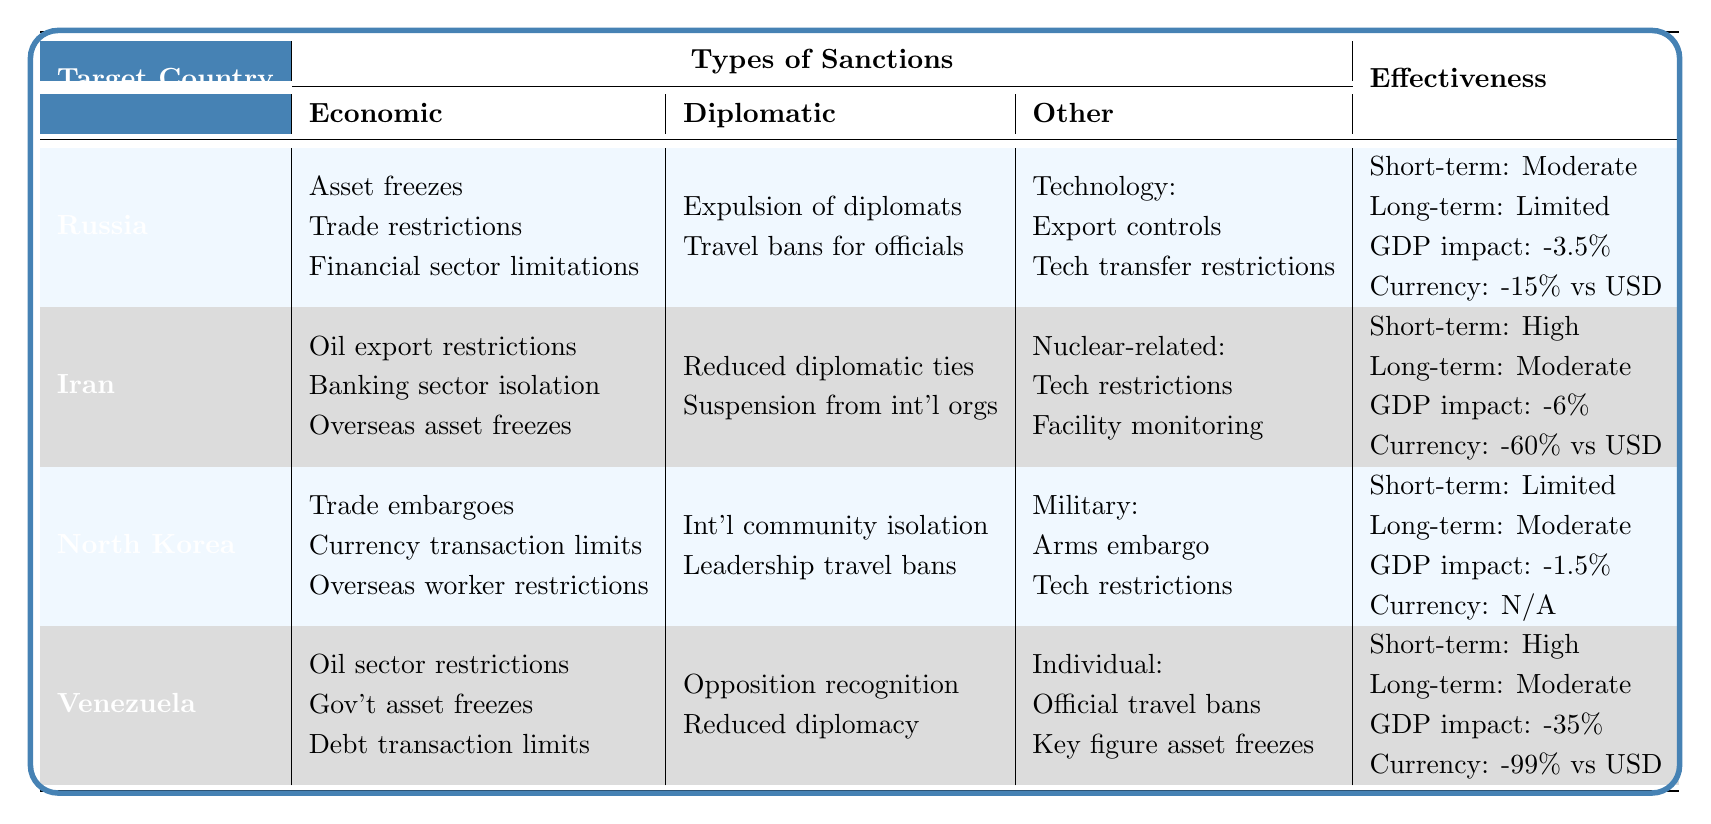What types of economic sanctions are imposed on Russia? From the table, the economic sanctions on Russia include asset freezes, trade restrictions, and financial sector limitations.
Answer: Asset freezes, trade restrictions, financial sector limitations What is the impact on Iran's currency due to sanctions? According to the table, the impact on Iran's currency is a decline of 60% against the USD.
Answer: -60% against USD Is the effectiveness of sanctions on North Korea considered high in the short term? The table indicates that the short-term effectiveness on North Korea is limited, not high.
Answer: No What is the average impact on GDP for the countries listed? To find the average GDP impact, we sum the impacts: -3.5% (Russia) + -6% (Iran) + -1.5% (North Korea) + -35% (Venezuela) = -46%. Then divide by 4 (number of countries), resulting in -46% / 4 = -11.5%.
Answer: -11.5% Do all targeted countries face long-term effectiveness classified as moderate? The table shows that while Iran and Venezuela have moderate long-term effectiveness, Russia has limited effectiveness, so not all do.
Answer: No Which country has the highest short-term effectiveness of sanctions? The table indicates that both Iran and Venezuela have high short-term effectiveness, but since the question asks for the highest, we refer to their equal status.
Answer: Iran and Venezuela What is the difference in GDP impact between Venezuela and North Korea? The GDP impact for Venezuela is -35% and for North Korea is -1.5%. The difference is -35% - (-1.5%) = -33.5%.
Answer: -33.5% How many types of sanctions are there for North Korea? For North Korea, there are three main types: Economic, Diplomatic, and Military sanctions.
Answer: 3 types What is the ratio of impact on currency for Venezuela compared to Russia? The impact on Venezuela's currency is -99% against the USD and for Russia, it's -15%. The ratio is -99% / -15% = 6.6.
Answer: 6.6 Which category of sanctions affects Iran's nuclear program? The table indicates that Iran's nuclear program is affected by restrictions on nuclear technology and monitoring of nuclear facilities, categorized as nuclear-related sanctions.
Answer: Nuclear-related sanctions Have diplomatic ties been reduced for all targeted countries? The table shows that diplomatic ties have been reduced for Iran and Venezuela, but not specifically for Russia and North Korea, indicating that not all have experienced this.
Answer: No 